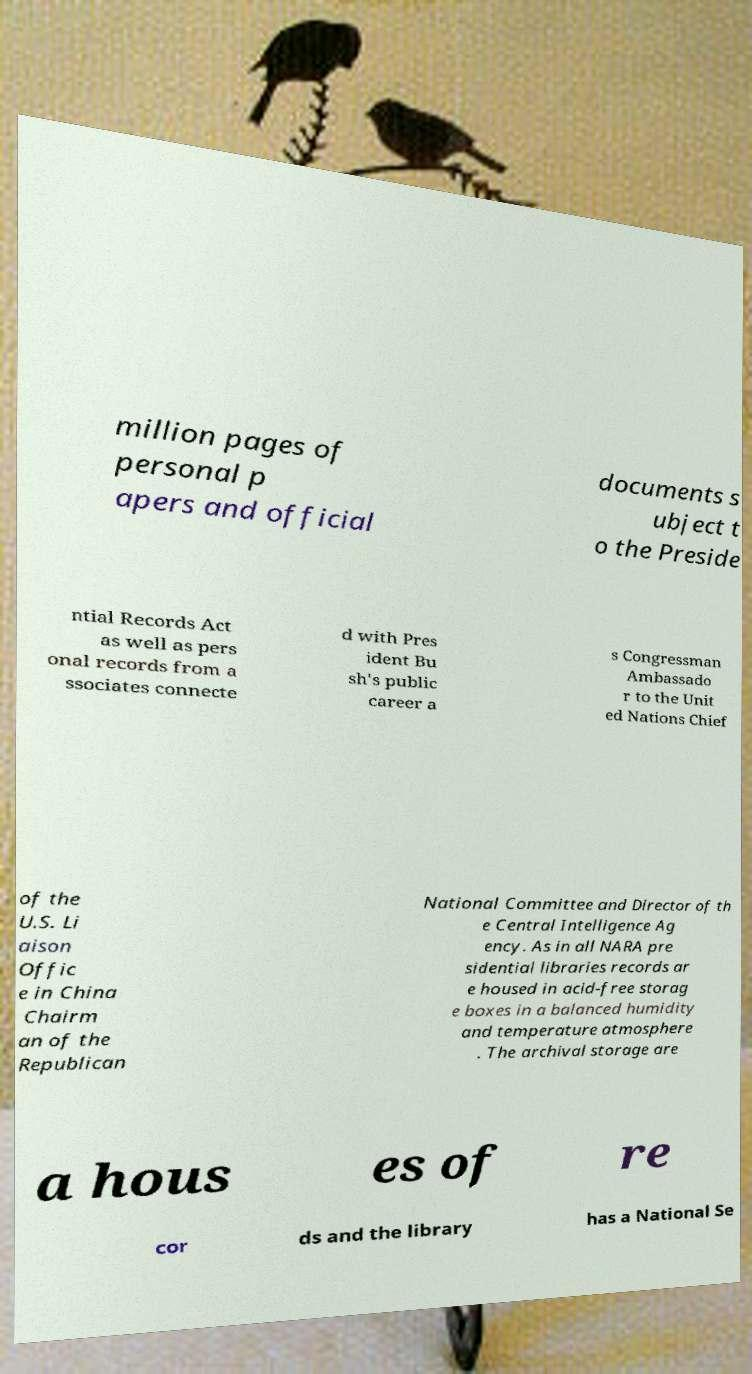Can you accurately transcribe the text from the provided image for me? million pages of personal p apers and official documents s ubject t o the Preside ntial Records Act as well as pers onal records from a ssociates connecte d with Pres ident Bu sh's public career a s Congressman Ambassado r to the Unit ed Nations Chief of the U.S. Li aison Offic e in China Chairm an of the Republican National Committee and Director of th e Central Intelligence Ag ency. As in all NARA pre sidential libraries records ar e housed in acid-free storag e boxes in a balanced humidity and temperature atmosphere . The archival storage are a hous es of re cor ds and the library has a National Se 